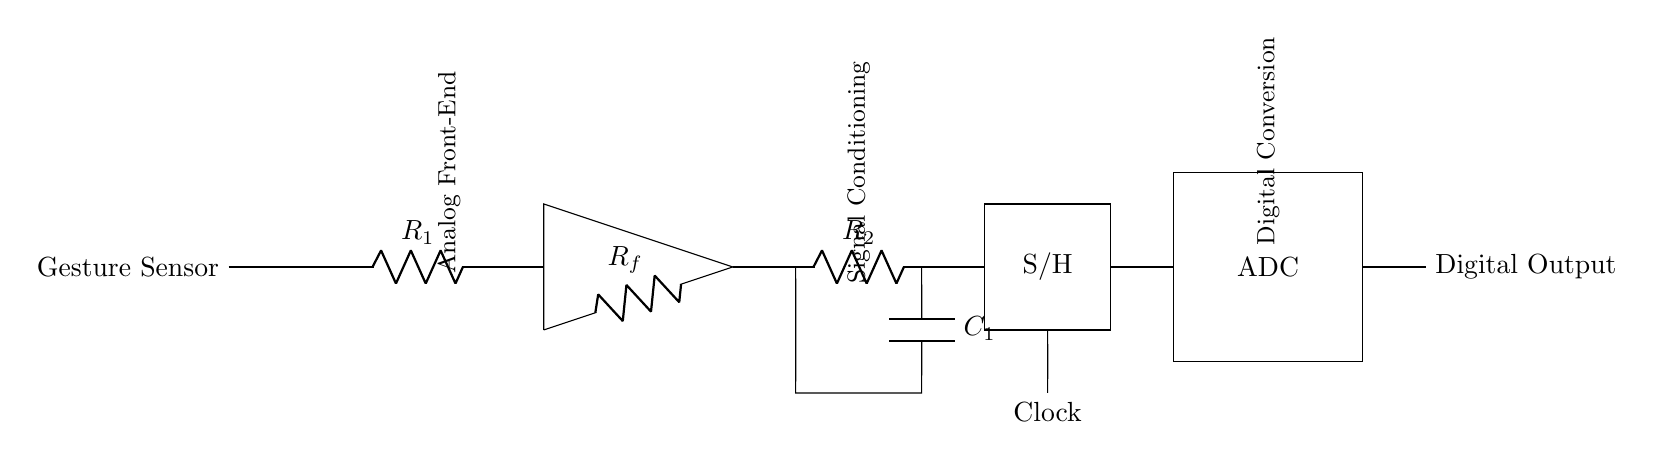What component is used for analog signal amplification? The circuit diagram shows an operational amplifier labeled as 'op amp.' This component is responsible for amplifying the analog signal from the gesture sensor before further processing.
Answer: op amp What is the purpose of the low-pass filter in this circuit? A low-pass filter allows signals below a certain frequency to pass and attenuates signals above that frequency. It smooths the amplified signal by removing high-frequency noise, facilitating cleaner signal processing for the ADC.
Answer: Signal smoothing What does 'S/H' stand for in this circuit? The 'S/H' stands for Sample and Hold. This circuit component captures and holds the voltage level of the incoming signal at a specific moment in time, which is essential before digitization through the ADC.
Answer: Sample and Hold How many resistors are present in the analog front-end section? The analog front-end consists of two resistors, R1 and Rf, as labeled in the diagram. They are crucial for determining the gain and input characteristics of the op amp in this stage.
Answer: Two What role does the clock play in the circuit? The clock synchronized timing signals in digital circuits like the ADC, ensuring that the analog signal sampled by the S/H component is accurately converted into a digital representation at specific intervals.
Answer: Synchronization What type of conversion does the ADC perform? The ADC converts analog signals into digital form. By doing so, it translates the continuous voltage levels from the signal conditioning section into discrete values that can be processed by digital systems.
Answer: Analog to digital 